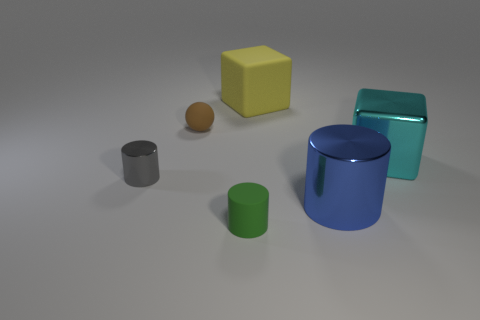Add 1 shiny objects. How many objects exist? 7 Subtract all cubes. How many objects are left? 4 Add 3 tiny yellow rubber cylinders. How many tiny yellow rubber cylinders exist? 3 Subtract 0 red cylinders. How many objects are left? 6 Subtract all tiny blue cylinders. Subtract all tiny green rubber cylinders. How many objects are left? 5 Add 4 large rubber objects. How many large rubber objects are left? 5 